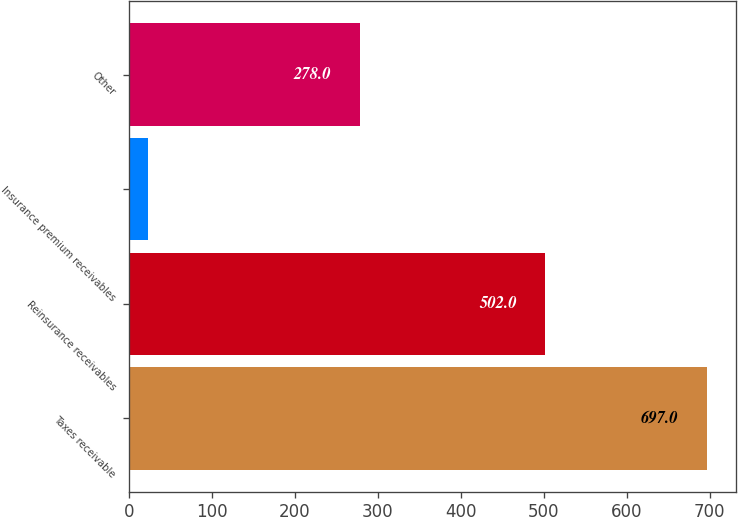Convert chart. <chart><loc_0><loc_0><loc_500><loc_500><bar_chart><fcel>Taxes receivable<fcel>Reinsurance receivables<fcel>Insurance premium receivables<fcel>Other<nl><fcel>697<fcel>502<fcel>23<fcel>278<nl></chart> 